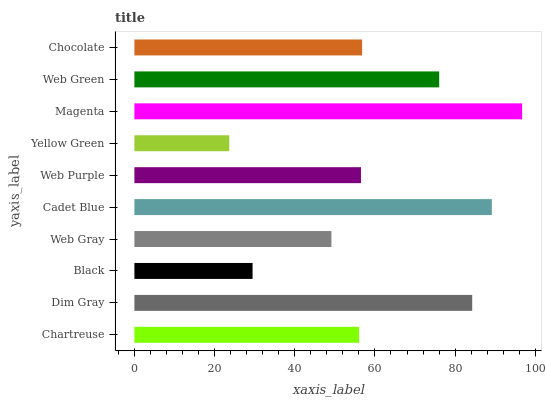Is Yellow Green the minimum?
Answer yes or no. Yes. Is Magenta the maximum?
Answer yes or no. Yes. Is Dim Gray the minimum?
Answer yes or no. No. Is Dim Gray the maximum?
Answer yes or no. No. Is Dim Gray greater than Chartreuse?
Answer yes or no. Yes. Is Chartreuse less than Dim Gray?
Answer yes or no. Yes. Is Chartreuse greater than Dim Gray?
Answer yes or no. No. Is Dim Gray less than Chartreuse?
Answer yes or no. No. Is Chocolate the high median?
Answer yes or no. Yes. Is Web Purple the low median?
Answer yes or no. Yes. Is Web Green the high median?
Answer yes or no. No. Is Yellow Green the low median?
Answer yes or no. No. 